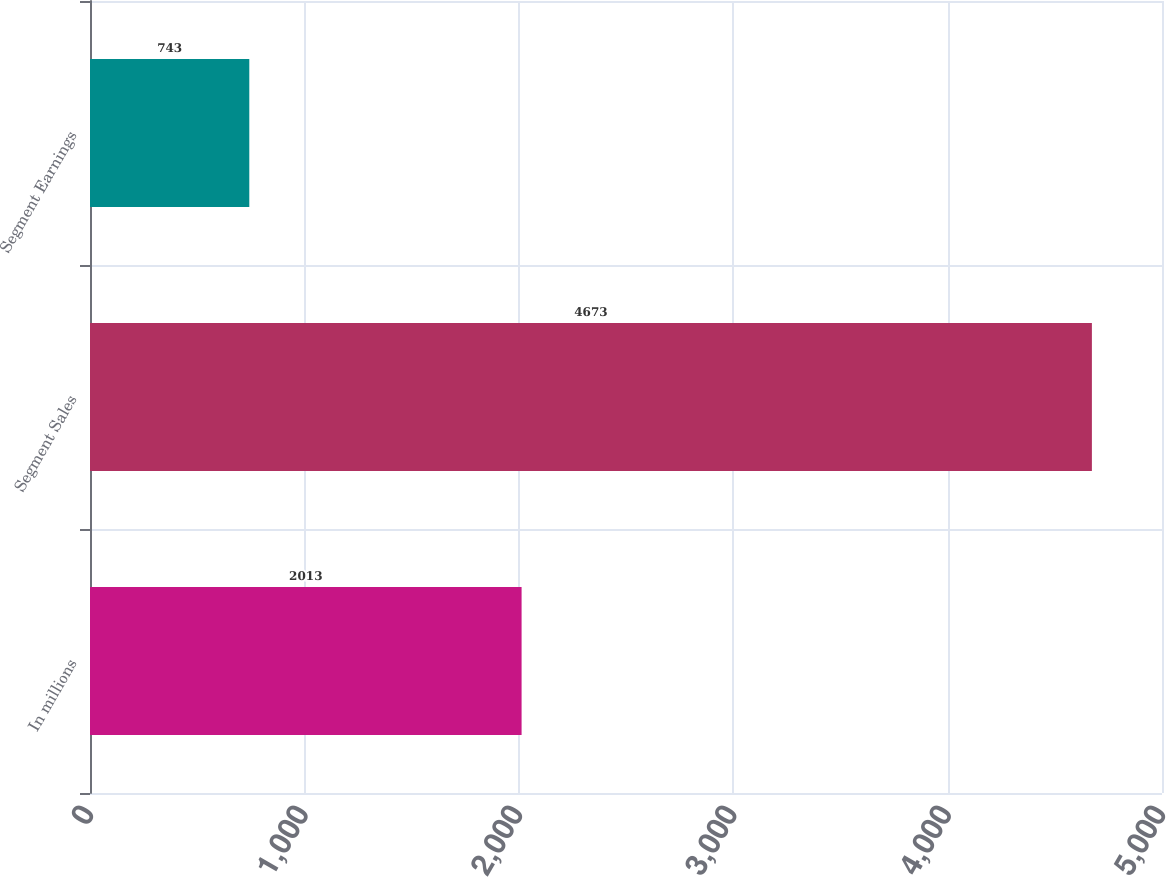Convert chart to OTSL. <chart><loc_0><loc_0><loc_500><loc_500><bar_chart><fcel>In millions<fcel>Segment Sales<fcel>Segment Earnings<nl><fcel>2013<fcel>4673<fcel>743<nl></chart> 